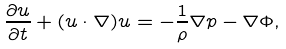Convert formula to latex. <formula><loc_0><loc_0><loc_500><loc_500>\frac { \partial { u } } { \partial t } + ( { u } \cdot \nabla ) { u } = - \frac { 1 } { \rho } \nabla p - \nabla \Phi ,</formula> 